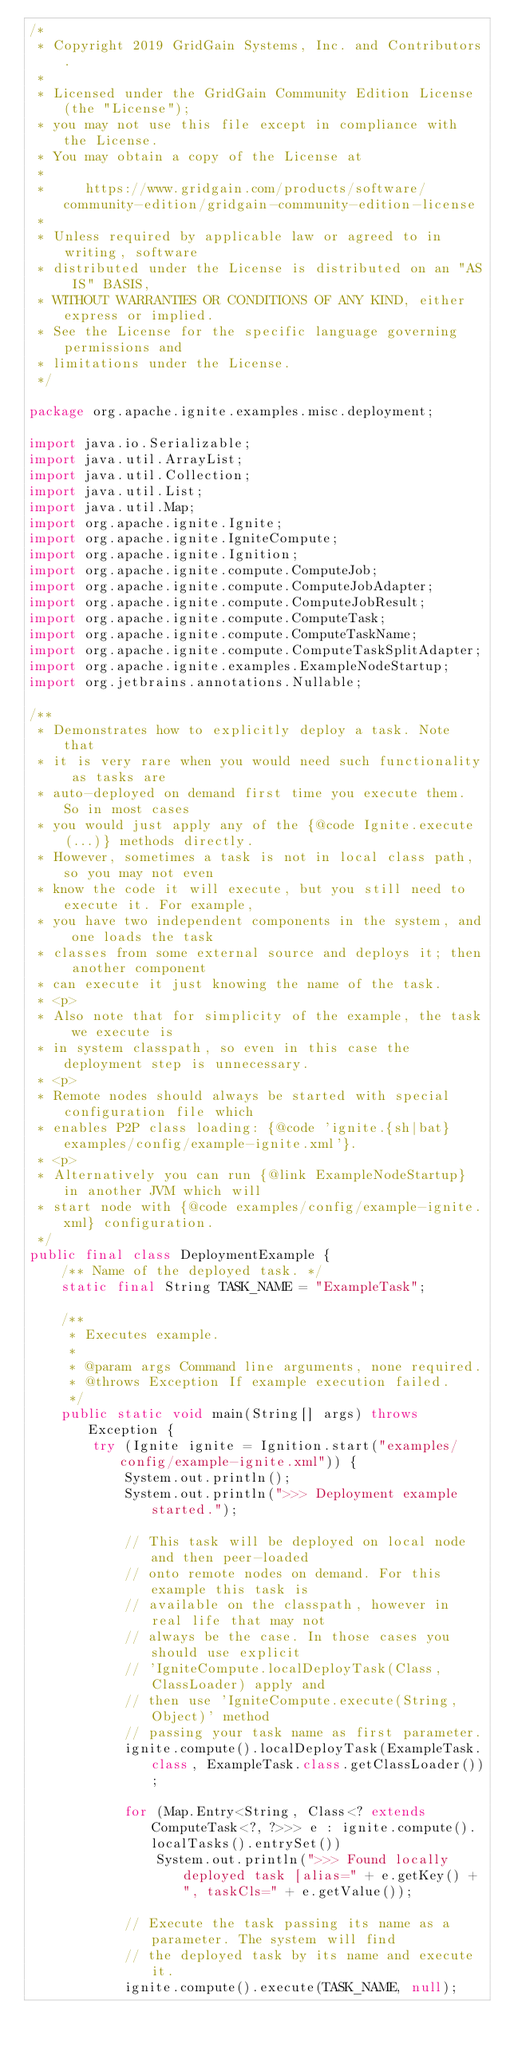<code> <loc_0><loc_0><loc_500><loc_500><_Java_>/*
 * Copyright 2019 GridGain Systems, Inc. and Contributors.
 *
 * Licensed under the GridGain Community Edition License (the "License");
 * you may not use this file except in compliance with the License.
 * You may obtain a copy of the License at
 *
 *     https://www.gridgain.com/products/software/community-edition/gridgain-community-edition-license
 *
 * Unless required by applicable law or agreed to in writing, software
 * distributed under the License is distributed on an "AS IS" BASIS,
 * WITHOUT WARRANTIES OR CONDITIONS OF ANY KIND, either express or implied.
 * See the License for the specific language governing permissions and
 * limitations under the License.
 */

package org.apache.ignite.examples.misc.deployment;

import java.io.Serializable;
import java.util.ArrayList;
import java.util.Collection;
import java.util.List;
import java.util.Map;
import org.apache.ignite.Ignite;
import org.apache.ignite.IgniteCompute;
import org.apache.ignite.Ignition;
import org.apache.ignite.compute.ComputeJob;
import org.apache.ignite.compute.ComputeJobAdapter;
import org.apache.ignite.compute.ComputeJobResult;
import org.apache.ignite.compute.ComputeTask;
import org.apache.ignite.compute.ComputeTaskName;
import org.apache.ignite.compute.ComputeTaskSplitAdapter;
import org.apache.ignite.examples.ExampleNodeStartup;
import org.jetbrains.annotations.Nullable;

/**
 * Demonstrates how to explicitly deploy a task. Note that
 * it is very rare when you would need such functionality as tasks are
 * auto-deployed on demand first time you execute them. So in most cases
 * you would just apply any of the {@code Ignite.execute(...)} methods directly.
 * However, sometimes a task is not in local class path, so you may not even
 * know the code it will execute, but you still need to execute it. For example,
 * you have two independent components in the system, and one loads the task
 * classes from some external source and deploys it; then another component
 * can execute it just knowing the name of the task.
 * <p>
 * Also note that for simplicity of the example, the task we execute is
 * in system classpath, so even in this case the deployment step is unnecessary.
 * <p>
 * Remote nodes should always be started with special configuration file which
 * enables P2P class loading: {@code 'ignite.{sh|bat} examples/config/example-ignite.xml'}.
 * <p>
 * Alternatively you can run {@link ExampleNodeStartup} in another JVM which will
 * start node with {@code examples/config/example-ignite.xml} configuration.
 */
public final class DeploymentExample {
    /** Name of the deployed task. */
    static final String TASK_NAME = "ExampleTask";

    /**
     * Executes example.
     *
     * @param args Command line arguments, none required.
     * @throws Exception If example execution failed.
     */
    public static void main(String[] args) throws Exception {
        try (Ignite ignite = Ignition.start("examples/config/example-ignite.xml")) {
            System.out.println();
            System.out.println(">>> Deployment example started.");

            // This task will be deployed on local node and then peer-loaded
            // onto remote nodes on demand. For this example this task is
            // available on the classpath, however in real life that may not
            // always be the case. In those cases you should use explicit
            // 'IgniteCompute.localDeployTask(Class, ClassLoader) apply and
            // then use 'IgniteCompute.execute(String, Object)' method
            // passing your task name as first parameter.
            ignite.compute().localDeployTask(ExampleTask.class, ExampleTask.class.getClassLoader());

            for (Map.Entry<String, Class<? extends ComputeTask<?, ?>>> e : ignite.compute().localTasks().entrySet())
                System.out.println(">>> Found locally deployed task [alias=" + e.getKey() + ", taskCls=" + e.getValue());

            // Execute the task passing its name as a parameter. The system will find
            // the deployed task by its name and execute it.
            ignite.compute().execute(TASK_NAME, null);
</code> 